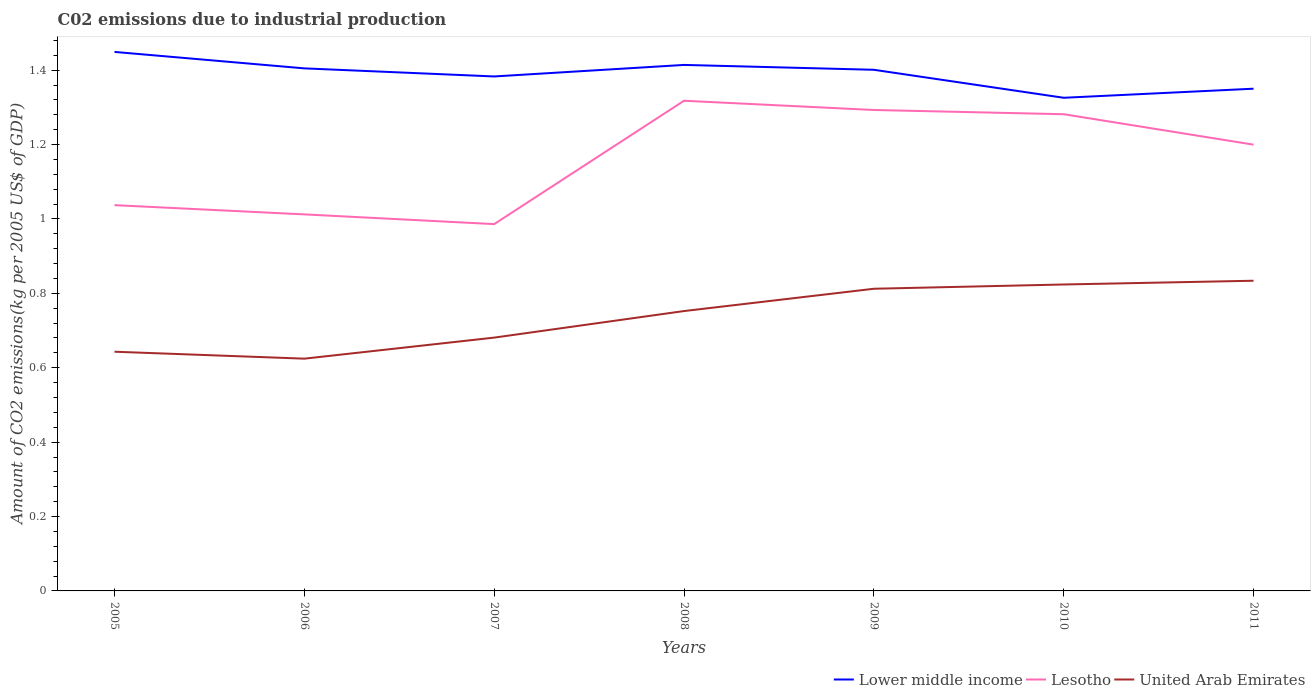How many different coloured lines are there?
Your answer should be very brief. 3. Across all years, what is the maximum amount of CO2 emitted due to industrial production in Lesotho?
Give a very brief answer. 0.99. In which year was the amount of CO2 emitted due to industrial production in Lower middle income maximum?
Offer a terse response. 2010. What is the total amount of CO2 emitted due to industrial production in Lower middle income in the graph?
Your answer should be very brief. 0.03. What is the difference between the highest and the second highest amount of CO2 emitted due to industrial production in Lesotho?
Ensure brevity in your answer.  0.33. Is the amount of CO2 emitted due to industrial production in United Arab Emirates strictly greater than the amount of CO2 emitted due to industrial production in Lower middle income over the years?
Ensure brevity in your answer.  Yes. How many lines are there?
Your answer should be compact. 3. Are the values on the major ticks of Y-axis written in scientific E-notation?
Provide a short and direct response. No. Does the graph contain any zero values?
Your response must be concise. No. Where does the legend appear in the graph?
Provide a succinct answer. Bottom right. How many legend labels are there?
Provide a succinct answer. 3. What is the title of the graph?
Your response must be concise. C02 emissions due to industrial production. Does "Papua New Guinea" appear as one of the legend labels in the graph?
Your response must be concise. No. What is the label or title of the X-axis?
Your answer should be compact. Years. What is the label or title of the Y-axis?
Your answer should be compact. Amount of CO2 emissions(kg per 2005 US$ of GDP). What is the Amount of CO2 emissions(kg per 2005 US$ of GDP) in Lower middle income in 2005?
Make the answer very short. 1.45. What is the Amount of CO2 emissions(kg per 2005 US$ of GDP) of Lesotho in 2005?
Ensure brevity in your answer.  1.04. What is the Amount of CO2 emissions(kg per 2005 US$ of GDP) of United Arab Emirates in 2005?
Your answer should be compact. 0.64. What is the Amount of CO2 emissions(kg per 2005 US$ of GDP) in Lower middle income in 2006?
Your response must be concise. 1.4. What is the Amount of CO2 emissions(kg per 2005 US$ of GDP) of Lesotho in 2006?
Your response must be concise. 1.01. What is the Amount of CO2 emissions(kg per 2005 US$ of GDP) of United Arab Emirates in 2006?
Offer a very short reply. 0.62. What is the Amount of CO2 emissions(kg per 2005 US$ of GDP) of Lower middle income in 2007?
Ensure brevity in your answer.  1.38. What is the Amount of CO2 emissions(kg per 2005 US$ of GDP) in Lesotho in 2007?
Keep it short and to the point. 0.99. What is the Amount of CO2 emissions(kg per 2005 US$ of GDP) of United Arab Emirates in 2007?
Give a very brief answer. 0.68. What is the Amount of CO2 emissions(kg per 2005 US$ of GDP) of Lower middle income in 2008?
Make the answer very short. 1.41. What is the Amount of CO2 emissions(kg per 2005 US$ of GDP) in Lesotho in 2008?
Provide a succinct answer. 1.32. What is the Amount of CO2 emissions(kg per 2005 US$ of GDP) in United Arab Emirates in 2008?
Give a very brief answer. 0.75. What is the Amount of CO2 emissions(kg per 2005 US$ of GDP) in Lower middle income in 2009?
Your response must be concise. 1.4. What is the Amount of CO2 emissions(kg per 2005 US$ of GDP) of Lesotho in 2009?
Provide a succinct answer. 1.29. What is the Amount of CO2 emissions(kg per 2005 US$ of GDP) in United Arab Emirates in 2009?
Your answer should be compact. 0.81. What is the Amount of CO2 emissions(kg per 2005 US$ of GDP) in Lower middle income in 2010?
Ensure brevity in your answer.  1.33. What is the Amount of CO2 emissions(kg per 2005 US$ of GDP) in Lesotho in 2010?
Give a very brief answer. 1.28. What is the Amount of CO2 emissions(kg per 2005 US$ of GDP) of United Arab Emirates in 2010?
Provide a succinct answer. 0.82. What is the Amount of CO2 emissions(kg per 2005 US$ of GDP) in Lower middle income in 2011?
Provide a succinct answer. 1.35. What is the Amount of CO2 emissions(kg per 2005 US$ of GDP) in Lesotho in 2011?
Provide a succinct answer. 1.2. What is the Amount of CO2 emissions(kg per 2005 US$ of GDP) in United Arab Emirates in 2011?
Make the answer very short. 0.83. Across all years, what is the maximum Amount of CO2 emissions(kg per 2005 US$ of GDP) of Lower middle income?
Offer a very short reply. 1.45. Across all years, what is the maximum Amount of CO2 emissions(kg per 2005 US$ of GDP) in Lesotho?
Keep it short and to the point. 1.32. Across all years, what is the maximum Amount of CO2 emissions(kg per 2005 US$ of GDP) of United Arab Emirates?
Provide a short and direct response. 0.83. Across all years, what is the minimum Amount of CO2 emissions(kg per 2005 US$ of GDP) of Lower middle income?
Provide a succinct answer. 1.33. Across all years, what is the minimum Amount of CO2 emissions(kg per 2005 US$ of GDP) in Lesotho?
Provide a short and direct response. 0.99. Across all years, what is the minimum Amount of CO2 emissions(kg per 2005 US$ of GDP) in United Arab Emirates?
Offer a terse response. 0.62. What is the total Amount of CO2 emissions(kg per 2005 US$ of GDP) of Lower middle income in the graph?
Offer a very short reply. 9.73. What is the total Amount of CO2 emissions(kg per 2005 US$ of GDP) in Lesotho in the graph?
Offer a very short reply. 8.13. What is the total Amount of CO2 emissions(kg per 2005 US$ of GDP) of United Arab Emirates in the graph?
Offer a terse response. 5.17. What is the difference between the Amount of CO2 emissions(kg per 2005 US$ of GDP) of Lower middle income in 2005 and that in 2006?
Your answer should be compact. 0.04. What is the difference between the Amount of CO2 emissions(kg per 2005 US$ of GDP) in Lesotho in 2005 and that in 2006?
Your answer should be compact. 0.02. What is the difference between the Amount of CO2 emissions(kg per 2005 US$ of GDP) of United Arab Emirates in 2005 and that in 2006?
Give a very brief answer. 0.02. What is the difference between the Amount of CO2 emissions(kg per 2005 US$ of GDP) of Lower middle income in 2005 and that in 2007?
Keep it short and to the point. 0.07. What is the difference between the Amount of CO2 emissions(kg per 2005 US$ of GDP) in Lesotho in 2005 and that in 2007?
Make the answer very short. 0.05. What is the difference between the Amount of CO2 emissions(kg per 2005 US$ of GDP) of United Arab Emirates in 2005 and that in 2007?
Offer a very short reply. -0.04. What is the difference between the Amount of CO2 emissions(kg per 2005 US$ of GDP) in Lower middle income in 2005 and that in 2008?
Make the answer very short. 0.04. What is the difference between the Amount of CO2 emissions(kg per 2005 US$ of GDP) of Lesotho in 2005 and that in 2008?
Your answer should be compact. -0.28. What is the difference between the Amount of CO2 emissions(kg per 2005 US$ of GDP) in United Arab Emirates in 2005 and that in 2008?
Give a very brief answer. -0.11. What is the difference between the Amount of CO2 emissions(kg per 2005 US$ of GDP) in Lower middle income in 2005 and that in 2009?
Provide a succinct answer. 0.05. What is the difference between the Amount of CO2 emissions(kg per 2005 US$ of GDP) in Lesotho in 2005 and that in 2009?
Provide a short and direct response. -0.26. What is the difference between the Amount of CO2 emissions(kg per 2005 US$ of GDP) of United Arab Emirates in 2005 and that in 2009?
Give a very brief answer. -0.17. What is the difference between the Amount of CO2 emissions(kg per 2005 US$ of GDP) in Lower middle income in 2005 and that in 2010?
Your answer should be very brief. 0.12. What is the difference between the Amount of CO2 emissions(kg per 2005 US$ of GDP) in Lesotho in 2005 and that in 2010?
Your response must be concise. -0.24. What is the difference between the Amount of CO2 emissions(kg per 2005 US$ of GDP) in United Arab Emirates in 2005 and that in 2010?
Your response must be concise. -0.18. What is the difference between the Amount of CO2 emissions(kg per 2005 US$ of GDP) of Lower middle income in 2005 and that in 2011?
Offer a terse response. 0.1. What is the difference between the Amount of CO2 emissions(kg per 2005 US$ of GDP) in Lesotho in 2005 and that in 2011?
Offer a terse response. -0.16. What is the difference between the Amount of CO2 emissions(kg per 2005 US$ of GDP) of United Arab Emirates in 2005 and that in 2011?
Give a very brief answer. -0.19. What is the difference between the Amount of CO2 emissions(kg per 2005 US$ of GDP) of Lower middle income in 2006 and that in 2007?
Offer a terse response. 0.02. What is the difference between the Amount of CO2 emissions(kg per 2005 US$ of GDP) in Lesotho in 2006 and that in 2007?
Give a very brief answer. 0.03. What is the difference between the Amount of CO2 emissions(kg per 2005 US$ of GDP) in United Arab Emirates in 2006 and that in 2007?
Your answer should be compact. -0.06. What is the difference between the Amount of CO2 emissions(kg per 2005 US$ of GDP) in Lower middle income in 2006 and that in 2008?
Make the answer very short. -0.01. What is the difference between the Amount of CO2 emissions(kg per 2005 US$ of GDP) of Lesotho in 2006 and that in 2008?
Provide a succinct answer. -0.31. What is the difference between the Amount of CO2 emissions(kg per 2005 US$ of GDP) of United Arab Emirates in 2006 and that in 2008?
Your answer should be compact. -0.13. What is the difference between the Amount of CO2 emissions(kg per 2005 US$ of GDP) of Lower middle income in 2006 and that in 2009?
Offer a terse response. 0. What is the difference between the Amount of CO2 emissions(kg per 2005 US$ of GDP) of Lesotho in 2006 and that in 2009?
Provide a short and direct response. -0.28. What is the difference between the Amount of CO2 emissions(kg per 2005 US$ of GDP) of United Arab Emirates in 2006 and that in 2009?
Your answer should be very brief. -0.19. What is the difference between the Amount of CO2 emissions(kg per 2005 US$ of GDP) of Lower middle income in 2006 and that in 2010?
Your response must be concise. 0.08. What is the difference between the Amount of CO2 emissions(kg per 2005 US$ of GDP) in Lesotho in 2006 and that in 2010?
Offer a very short reply. -0.27. What is the difference between the Amount of CO2 emissions(kg per 2005 US$ of GDP) of United Arab Emirates in 2006 and that in 2010?
Your answer should be very brief. -0.2. What is the difference between the Amount of CO2 emissions(kg per 2005 US$ of GDP) in Lower middle income in 2006 and that in 2011?
Provide a succinct answer. 0.05. What is the difference between the Amount of CO2 emissions(kg per 2005 US$ of GDP) in Lesotho in 2006 and that in 2011?
Offer a very short reply. -0.19. What is the difference between the Amount of CO2 emissions(kg per 2005 US$ of GDP) of United Arab Emirates in 2006 and that in 2011?
Provide a short and direct response. -0.21. What is the difference between the Amount of CO2 emissions(kg per 2005 US$ of GDP) of Lower middle income in 2007 and that in 2008?
Provide a succinct answer. -0.03. What is the difference between the Amount of CO2 emissions(kg per 2005 US$ of GDP) of Lesotho in 2007 and that in 2008?
Your answer should be compact. -0.33. What is the difference between the Amount of CO2 emissions(kg per 2005 US$ of GDP) in United Arab Emirates in 2007 and that in 2008?
Your answer should be very brief. -0.07. What is the difference between the Amount of CO2 emissions(kg per 2005 US$ of GDP) of Lower middle income in 2007 and that in 2009?
Offer a very short reply. -0.02. What is the difference between the Amount of CO2 emissions(kg per 2005 US$ of GDP) of Lesotho in 2007 and that in 2009?
Offer a terse response. -0.31. What is the difference between the Amount of CO2 emissions(kg per 2005 US$ of GDP) in United Arab Emirates in 2007 and that in 2009?
Make the answer very short. -0.13. What is the difference between the Amount of CO2 emissions(kg per 2005 US$ of GDP) in Lower middle income in 2007 and that in 2010?
Your answer should be compact. 0.06. What is the difference between the Amount of CO2 emissions(kg per 2005 US$ of GDP) in Lesotho in 2007 and that in 2010?
Keep it short and to the point. -0.3. What is the difference between the Amount of CO2 emissions(kg per 2005 US$ of GDP) of United Arab Emirates in 2007 and that in 2010?
Give a very brief answer. -0.14. What is the difference between the Amount of CO2 emissions(kg per 2005 US$ of GDP) in Lower middle income in 2007 and that in 2011?
Make the answer very short. 0.03. What is the difference between the Amount of CO2 emissions(kg per 2005 US$ of GDP) of Lesotho in 2007 and that in 2011?
Offer a very short reply. -0.21. What is the difference between the Amount of CO2 emissions(kg per 2005 US$ of GDP) in United Arab Emirates in 2007 and that in 2011?
Offer a very short reply. -0.15. What is the difference between the Amount of CO2 emissions(kg per 2005 US$ of GDP) in Lower middle income in 2008 and that in 2009?
Your answer should be compact. 0.01. What is the difference between the Amount of CO2 emissions(kg per 2005 US$ of GDP) of Lesotho in 2008 and that in 2009?
Offer a very short reply. 0.02. What is the difference between the Amount of CO2 emissions(kg per 2005 US$ of GDP) of United Arab Emirates in 2008 and that in 2009?
Offer a terse response. -0.06. What is the difference between the Amount of CO2 emissions(kg per 2005 US$ of GDP) in Lower middle income in 2008 and that in 2010?
Your response must be concise. 0.09. What is the difference between the Amount of CO2 emissions(kg per 2005 US$ of GDP) in Lesotho in 2008 and that in 2010?
Provide a succinct answer. 0.04. What is the difference between the Amount of CO2 emissions(kg per 2005 US$ of GDP) in United Arab Emirates in 2008 and that in 2010?
Ensure brevity in your answer.  -0.07. What is the difference between the Amount of CO2 emissions(kg per 2005 US$ of GDP) of Lower middle income in 2008 and that in 2011?
Ensure brevity in your answer.  0.06. What is the difference between the Amount of CO2 emissions(kg per 2005 US$ of GDP) in Lesotho in 2008 and that in 2011?
Keep it short and to the point. 0.12. What is the difference between the Amount of CO2 emissions(kg per 2005 US$ of GDP) of United Arab Emirates in 2008 and that in 2011?
Make the answer very short. -0.08. What is the difference between the Amount of CO2 emissions(kg per 2005 US$ of GDP) in Lower middle income in 2009 and that in 2010?
Ensure brevity in your answer.  0.08. What is the difference between the Amount of CO2 emissions(kg per 2005 US$ of GDP) in Lesotho in 2009 and that in 2010?
Offer a terse response. 0.01. What is the difference between the Amount of CO2 emissions(kg per 2005 US$ of GDP) in United Arab Emirates in 2009 and that in 2010?
Give a very brief answer. -0.01. What is the difference between the Amount of CO2 emissions(kg per 2005 US$ of GDP) of Lower middle income in 2009 and that in 2011?
Make the answer very short. 0.05. What is the difference between the Amount of CO2 emissions(kg per 2005 US$ of GDP) in Lesotho in 2009 and that in 2011?
Your answer should be very brief. 0.09. What is the difference between the Amount of CO2 emissions(kg per 2005 US$ of GDP) of United Arab Emirates in 2009 and that in 2011?
Make the answer very short. -0.02. What is the difference between the Amount of CO2 emissions(kg per 2005 US$ of GDP) of Lower middle income in 2010 and that in 2011?
Give a very brief answer. -0.02. What is the difference between the Amount of CO2 emissions(kg per 2005 US$ of GDP) in Lesotho in 2010 and that in 2011?
Provide a succinct answer. 0.08. What is the difference between the Amount of CO2 emissions(kg per 2005 US$ of GDP) of United Arab Emirates in 2010 and that in 2011?
Provide a succinct answer. -0.01. What is the difference between the Amount of CO2 emissions(kg per 2005 US$ of GDP) in Lower middle income in 2005 and the Amount of CO2 emissions(kg per 2005 US$ of GDP) in Lesotho in 2006?
Provide a short and direct response. 0.44. What is the difference between the Amount of CO2 emissions(kg per 2005 US$ of GDP) of Lower middle income in 2005 and the Amount of CO2 emissions(kg per 2005 US$ of GDP) of United Arab Emirates in 2006?
Ensure brevity in your answer.  0.82. What is the difference between the Amount of CO2 emissions(kg per 2005 US$ of GDP) of Lesotho in 2005 and the Amount of CO2 emissions(kg per 2005 US$ of GDP) of United Arab Emirates in 2006?
Your response must be concise. 0.41. What is the difference between the Amount of CO2 emissions(kg per 2005 US$ of GDP) of Lower middle income in 2005 and the Amount of CO2 emissions(kg per 2005 US$ of GDP) of Lesotho in 2007?
Provide a succinct answer. 0.46. What is the difference between the Amount of CO2 emissions(kg per 2005 US$ of GDP) of Lower middle income in 2005 and the Amount of CO2 emissions(kg per 2005 US$ of GDP) of United Arab Emirates in 2007?
Make the answer very short. 0.77. What is the difference between the Amount of CO2 emissions(kg per 2005 US$ of GDP) of Lesotho in 2005 and the Amount of CO2 emissions(kg per 2005 US$ of GDP) of United Arab Emirates in 2007?
Your response must be concise. 0.36. What is the difference between the Amount of CO2 emissions(kg per 2005 US$ of GDP) of Lower middle income in 2005 and the Amount of CO2 emissions(kg per 2005 US$ of GDP) of Lesotho in 2008?
Your answer should be compact. 0.13. What is the difference between the Amount of CO2 emissions(kg per 2005 US$ of GDP) of Lower middle income in 2005 and the Amount of CO2 emissions(kg per 2005 US$ of GDP) of United Arab Emirates in 2008?
Give a very brief answer. 0.7. What is the difference between the Amount of CO2 emissions(kg per 2005 US$ of GDP) of Lesotho in 2005 and the Amount of CO2 emissions(kg per 2005 US$ of GDP) of United Arab Emirates in 2008?
Give a very brief answer. 0.28. What is the difference between the Amount of CO2 emissions(kg per 2005 US$ of GDP) of Lower middle income in 2005 and the Amount of CO2 emissions(kg per 2005 US$ of GDP) of Lesotho in 2009?
Your answer should be compact. 0.16. What is the difference between the Amount of CO2 emissions(kg per 2005 US$ of GDP) in Lower middle income in 2005 and the Amount of CO2 emissions(kg per 2005 US$ of GDP) in United Arab Emirates in 2009?
Your answer should be very brief. 0.64. What is the difference between the Amount of CO2 emissions(kg per 2005 US$ of GDP) of Lesotho in 2005 and the Amount of CO2 emissions(kg per 2005 US$ of GDP) of United Arab Emirates in 2009?
Make the answer very short. 0.22. What is the difference between the Amount of CO2 emissions(kg per 2005 US$ of GDP) of Lower middle income in 2005 and the Amount of CO2 emissions(kg per 2005 US$ of GDP) of Lesotho in 2010?
Your response must be concise. 0.17. What is the difference between the Amount of CO2 emissions(kg per 2005 US$ of GDP) of Lower middle income in 2005 and the Amount of CO2 emissions(kg per 2005 US$ of GDP) of United Arab Emirates in 2010?
Make the answer very short. 0.63. What is the difference between the Amount of CO2 emissions(kg per 2005 US$ of GDP) in Lesotho in 2005 and the Amount of CO2 emissions(kg per 2005 US$ of GDP) in United Arab Emirates in 2010?
Your response must be concise. 0.21. What is the difference between the Amount of CO2 emissions(kg per 2005 US$ of GDP) in Lower middle income in 2005 and the Amount of CO2 emissions(kg per 2005 US$ of GDP) in Lesotho in 2011?
Offer a terse response. 0.25. What is the difference between the Amount of CO2 emissions(kg per 2005 US$ of GDP) of Lower middle income in 2005 and the Amount of CO2 emissions(kg per 2005 US$ of GDP) of United Arab Emirates in 2011?
Your answer should be very brief. 0.62. What is the difference between the Amount of CO2 emissions(kg per 2005 US$ of GDP) in Lesotho in 2005 and the Amount of CO2 emissions(kg per 2005 US$ of GDP) in United Arab Emirates in 2011?
Ensure brevity in your answer.  0.2. What is the difference between the Amount of CO2 emissions(kg per 2005 US$ of GDP) in Lower middle income in 2006 and the Amount of CO2 emissions(kg per 2005 US$ of GDP) in Lesotho in 2007?
Offer a terse response. 0.42. What is the difference between the Amount of CO2 emissions(kg per 2005 US$ of GDP) in Lower middle income in 2006 and the Amount of CO2 emissions(kg per 2005 US$ of GDP) in United Arab Emirates in 2007?
Offer a terse response. 0.72. What is the difference between the Amount of CO2 emissions(kg per 2005 US$ of GDP) of Lesotho in 2006 and the Amount of CO2 emissions(kg per 2005 US$ of GDP) of United Arab Emirates in 2007?
Your answer should be very brief. 0.33. What is the difference between the Amount of CO2 emissions(kg per 2005 US$ of GDP) of Lower middle income in 2006 and the Amount of CO2 emissions(kg per 2005 US$ of GDP) of Lesotho in 2008?
Offer a terse response. 0.09. What is the difference between the Amount of CO2 emissions(kg per 2005 US$ of GDP) in Lower middle income in 2006 and the Amount of CO2 emissions(kg per 2005 US$ of GDP) in United Arab Emirates in 2008?
Offer a very short reply. 0.65. What is the difference between the Amount of CO2 emissions(kg per 2005 US$ of GDP) in Lesotho in 2006 and the Amount of CO2 emissions(kg per 2005 US$ of GDP) in United Arab Emirates in 2008?
Provide a succinct answer. 0.26. What is the difference between the Amount of CO2 emissions(kg per 2005 US$ of GDP) of Lower middle income in 2006 and the Amount of CO2 emissions(kg per 2005 US$ of GDP) of Lesotho in 2009?
Your response must be concise. 0.11. What is the difference between the Amount of CO2 emissions(kg per 2005 US$ of GDP) in Lower middle income in 2006 and the Amount of CO2 emissions(kg per 2005 US$ of GDP) in United Arab Emirates in 2009?
Give a very brief answer. 0.59. What is the difference between the Amount of CO2 emissions(kg per 2005 US$ of GDP) of Lesotho in 2006 and the Amount of CO2 emissions(kg per 2005 US$ of GDP) of United Arab Emirates in 2009?
Keep it short and to the point. 0.2. What is the difference between the Amount of CO2 emissions(kg per 2005 US$ of GDP) in Lower middle income in 2006 and the Amount of CO2 emissions(kg per 2005 US$ of GDP) in Lesotho in 2010?
Your answer should be compact. 0.12. What is the difference between the Amount of CO2 emissions(kg per 2005 US$ of GDP) of Lower middle income in 2006 and the Amount of CO2 emissions(kg per 2005 US$ of GDP) of United Arab Emirates in 2010?
Ensure brevity in your answer.  0.58. What is the difference between the Amount of CO2 emissions(kg per 2005 US$ of GDP) in Lesotho in 2006 and the Amount of CO2 emissions(kg per 2005 US$ of GDP) in United Arab Emirates in 2010?
Your response must be concise. 0.19. What is the difference between the Amount of CO2 emissions(kg per 2005 US$ of GDP) in Lower middle income in 2006 and the Amount of CO2 emissions(kg per 2005 US$ of GDP) in Lesotho in 2011?
Ensure brevity in your answer.  0.21. What is the difference between the Amount of CO2 emissions(kg per 2005 US$ of GDP) of Lower middle income in 2006 and the Amount of CO2 emissions(kg per 2005 US$ of GDP) of United Arab Emirates in 2011?
Your answer should be compact. 0.57. What is the difference between the Amount of CO2 emissions(kg per 2005 US$ of GDP) in Lesotho in 2006 and the Amount of CO2 emissions(kg per 2005 US$ of GDP) in United Arab Emirates in 2011?
Provide a short and direct response. 0.18. What is the difference between the Amount of CO2 emissions(kg per 2005 US$ of GDP) of Lower middle income in 2007 and the Amount of CO2 emissions(kg per 2005 US$ of GDP) of Lesotho in 2008?
Ensure brevity in your answer.  0.07. What is the difference between the Amount of CO2 emissions(kg per 2005 US$ of GDP) in Lower middle income in 2007 and the Amount of CO2 emissions(kg per 2005 US$ of GDP) in United Arab Emirates in 2008?
Your answer should be very brief. 0.63. What is the difference between the Amount of CO2 emissions(kg per 2005 US$ of GDP) in Lesotho in 2007 and the Amount of CO2 emissions(kg per 2005 US$ of GDP) in United Arab Emirates in 2008?
Your answer should be very brief. 0.23. What is the difference between the Amount of CO2 emissions(kg per 2005 US$ of GDP) of Lower middle income in 2007 and the Amount of CO2 emissions(kg per 2005 US$ of GDP) of Lesotho in 2009?
Provide a succinct answer. 0.09. What is the difference between the Amount of CO2 emissions(kg per 2005 US$ of GDP) of Lower middle income in 2007 and the Amount of CO2 emissions(kg per 2005 US$ of GDP) of United Arab Emirates in 2009?
Your response must be concise. 0.57. What is the difference between the Amount of CO2 emissions(kg per 2005 US$ of GDP) in Lesotho in 2007 and the Amount of CO2 emissions(kg per 2005 US$ of GDP) in United Arab Emirates in 2009?
Ensure brevity in your answer.  0.17. What is the difference between the Amount of CO2 emissions(kg per 2005 US$ of GDP) of Lower middle income in 2007 and the Amount of CO2 emissions(kg per 2005 US$ of GDP) of Lesotho in 2010?
Offer a terse response. 0.1. What is the difference between the Amount of CO2 emissions(kg per 2005 US$ of GDP) in Lower middle income in 2007 and the Amount of CO2 emissions(kg per 2005 US$ of GDP) in United Arab Emirates in 2010?
Provide a succinct answer. 0.56. What is the difference between the Amount of CO2 emissions(kg per 2005 US$ of GDP) in Lesotho in 2007 and the Amount of CO2 emissions(kg per 2005 US$ of GDP) in United Arab Emirates in 2010?
Make the answer very short. 0.16. What is the difference between the Amount of CO2 emissions(kg per 2005 US$ of GDP) of Lower middle income in 2007 and the Amount of CO2 emissions(kg per 2005 US$ of GDP) of Lesotho in 2011?
Your answer should be compact. 0.18. What is the difference between the Amount of CO2 emissions(kg per 2005 US$ of GDP) of Lower middle income in 2007 and the Amount of CO2 emissions(kg per 2005 US$ of GDP) of United Arab Emirates in 2011?
Offer a terse response. 0.55. What is the difference between the Amount of CO2 emissions(kg per 2005 US$ of GDP) of Lesotho in 2007 and the Amount of CO2 emissions(kg per 2005 US$ of GDP) of United Arab Emirates in 2011?
Make the answer very short. 0.15. What is the difference between the Amount of CO2 emissions(kg per 2005 US$ of GDP) in Lower middle income in 2008 and the Amount of CO2 emissions(kg per 2005 US$ of GDP) in Lesotho in 2009?
Offer a terse response. 0.12. What is the difference between the Amount of CO2 emissions(kg per 2005 US$ of GDP) in Lower middle income in 2008 and the Amount of CO2 emissions(kg per 2005 US$ of GDP) in United Arab Emirates in 2009?
Provide a succinct answer. 0.6. What is the difference between the Amount of CO2 emissions(kg per 2005 US$ of GDP) in Lesotho in 2008 and the Amount of CO2 emissions(kg per 2005 US$ of GDP) in United Arab Emirates in 2009?
Keep it short and to the point. 0.51. What is the difference between the Amount of CO2 emissions(kg per 2005 US$ of GDP) of Lower middle income in 2008 and the Amount of CO2 emissions(kg per 2005 US$ of GDP) of Lesotho in 2010?
Offer a terse response. 0.13. What is the difference between the Amount of CO2 emissions(kg per 2005 US$ of GDP) in Lower middle income in 2008 and the Amount of CO2 emissions(kg per 2005 US$ of GDP) in United Arab Emirates in 2010?
Your response must be concise. 0.59. What is the difference between the Amount of CO2 emissions(kg per 2005 US$ of GDP) in Lesotho in 2008 and the Amount of CO2 emissions(kg per 2005 US$ of GDP) in United Arab Emirates in 2010?
Your answer should be compact. 0.49. What is the difference between the Amount of CO2 emissions(kg per 2005 US$ of GDP) in Lower middle income in 2008 and the Amount of CO2 emissions(kg per 2005 US$ of GDP) in Lesotho in 2011?
Make the answer very short. 0.21. What is the difference between the Amount of CO2 emissions(kg per 2005 US$ of GDP) of Lower middle income in 2008 and the Amount of CO2 emissions(kg per 2005 US$ of GDP) of United Arab Emirates in 2011?
Provide a succinct answer. 0.58. What is the difference between the Amount of CO2 emissions(kg per 2005 US$ of GDP) in Lesotho in 2008 and the Amount of CO2 emissions(kg per 2005 US$ of GDP) in United Arab Emirates in 2011?
Offer a very short reply. 0.48. What is the difference between the Amount of CO2 emissions(kg per 2005 US$ of GDP) of Lower middle income in 2009 and the Amount of CO2 emissions(kg per 2005 US$ of GDP) of Lesotho in 2010?
Provide a short and direct response. 0.12. What is the difference between the Amount of CO2 emissions(kg per 2005 US$ of GDP) of Lower middle income in 2009 and the Amount of CO2 emissions(kg per 2005 US$ of GDP) of United Arab Emirates in 2010?
Give a very brief answer. 0.58. What is the difference between the Amount of CO2 emissions(kg per 2005 US$ of GDP) in Lesotho in 2009 and the Amount of CO2 emissions(kg per 2005 US$ of GDP) in United Arab Emirates in 2010?
Provide a short and direct response. 0.47. What is the difference between the Amount of CO2 emissions(kg per 2005 US$ of GDP) in Lower middle income in 2009 and the Amount of CO2 emissions(kg per 2005 US$ of GDP) in Lesotho in 2011?
Make the answer very short. 0.2. What is the difference between the Amount of CO2 emissions(kg per 2005 US$ of GDP) of Lower middle income in 2009 and the Amount of CO2 emissions(kg per 2005 US$ of GDP) of United Arab Emirates in 2011?
Your answer should be very brief. 0.57. What is the difference between the Amount of CO2 emissions(kg per 2005 US$ of GDP) of Lesotho in 2009 and the Amount of CO2 emissions(kg per 2005 US$ of GDP) of United Arab Emirates in 2011?
Ensure brevity in your answer.  0.46. What is the difference between the Amount of CO2 emissions(kg per 2005 US$ of GDP) of Lower middle income in 2010 and the Amount of CO2 emissions(kg per 2005 US$ of GDP) of Lesotho in 2011?
Provide a short and direct response. 0.13. What is the difference between the Amount of CO2 emissions(kg per 2005 US$ of GDP) in Lower middle income in 2010 and the Amount of CO2 emissions(kg per 2005 US$ of GDP) in United Arab Emirates in 2011?
Offer a very short reply. 0.49. What is the difference between the Amount of CO2 emissions(kg per 2005 US$ of GDP) of Lesotho in 2010 and the Amount of CO2 emissions(kg per 2005 US$ of GDP) of United Arab Emirates in 2011?
Make the answer very short. 0.45. What is the average Amount of CO2 emissions(kg per 2005 US$ of GDP) of Lower middle income per year?
Make the answer very short. 1.39. What is the average Amount of CO2 emissions(kg per 2005 US$ of GDP) in Lesotho per year?
Keep it short and to the point. 1.16. What is the average Amount of CO2 emissions(kg per 2005 US$ of GDP) in United Arab Emirates per year?
Provide a short and direct response. 0.74. In the year 2005, what is the difference between the Amount of CO2 emissions(kg per 2005 US$ of GDP) in Lower middle income and Amount of CO2 emissions(kg per 2005 US$ of GDP) in Lesotho?
Keep it short and to the point. 0.41. In the year 2005, what is the difference between the Amount of CO2 emissions(kg per 2005 US$ of GDP) in Lower middle income and Amount of CO2 emissions(kg per 2005 US$ of GDP) in United Arab Emirates?
Provide a short and direct response. 0.81. In the year 2005, what is the difference between the Amount of CO2 emissions(kg per 2005 US$ of GDP) of Lesotho and Amount of CO2 emissions(kg per 2005 US$ of GDP) of United Arab Emirates?
Your response must be concise. 0.39. In the year 2006, what is the difference between the Amount of CO2 emissions(kg per 2005 US$ of GDP) of Lower middle income and Amount of CO2 emissions(kg per 2005 US$ of GDP) of Lesotho?
Provide a succinct answer. 0.39. In the year 2006, what is the difference between the Amount of CO2 emissions(kg per 2005 US$ of GDP) of Lower middle income and Amount of CO2 emissions(kg per 2005 US$ of GDP) of United Arab Emirates?
Offer a terse response. 0.78. In the year 2006, what is the difference between the Amount of CO2 emissions(kg per 2005 US$ of GDP) in Lesotho and Amount of CO2 emissions(kg per 2005 US$ of GDP) in United Arab Emirates?
Keep it short and to the point. 0.39. In the year 2007, what is the difference between the Amount of CO2 emissions(kg per 2005 US$ of GDP) in Lower middle income and Amount of CO2 emissions(kg per 2005 US$ of GDP) in Lesotho?
Ensure brevity in your answer.  0.4. In the year 2007, what is the difference between the Amount of CO2 emissions(kg per 2005 US$ of GDP) in Lower middle income and Amount of CO2 emissions(kg per 2005 US$ of GDP) in United Arab Emirates?
Make the answer very short. 0.7. In the year 2007, what is the difference between the Amount of CO2 emissions(kg per 2005 US$ of GDP) of Lesotho and Amount of CO2 emissions(kg per 2005 US$ of GDP) of United Arab Emirates?
Make the answer very short. 0.31. In the year 2008, what is the difference between the Amount of CO2 emissions(kg per 2005 US$ of GDP) of Lower middle income and Amount of CO2 emissions(kg per 2005 US$ of GDP) of Lesotho?
Your answer should be compact. 0.1. In the year 2008, what is the difference between the Amount of CO2 emissions(kg per 2005 US$ of GDP) in Lower middle income and Amount of CO2 emissions(kg per 2005 US$ of GDP) in United Arab Emirates?
Provide a succinct answer. 0.66. In the year 2008, what is the difference between the Amount of CO2 emissions(kg per 2005 US$ of GDP) of Lesotho and Amount of CO2 emissions(kg per 2005 US$ of GDP) of United Arab Emirates?
Ensure brevity in your answer.  0.57. In the year 2009, what is the difference between the Amount of CO2 emissions(kg per 2005 US$ of GDP) of Lower middle income and Amount of CO2 emissions(kg per 2005 US$ of GDP) of Lesotho?
Ensure brevity in your answer.  0.11. In the year 2009, what is the difference between the Amount of CO2 emissions(kg per 2005 US$ of GDP) in Lower middle income and Amount of CO2 emissions(kg per 2005 US$ of GDP) in United Arab Emirates?
Give a very brief answer. 0.59. In the year 2009, what is the difference between the Amount of CO2 emissions(kg per 2005 US$ of GDP) in Lesotho and Amount of CO2 emissions(kg per 2005 US$ of GDP) in United Arab Emirates?
Make the answer very short. 0.48. In the year 2010, what is the difference between the Amount of CO2 emissions(kg per 2005 US$ of GDP) of Lower middle income and Amount of CO2 emissions(kg per 2005 US$ of GDP) of Lesotho?
Keep it short and to the point. 0.04. In the year 2010, what is the difference between the Amount of CO2 emissions(kg per 2005 US$ of GDP) in Lower middle income and Amount of CO2 emissions(kg per 2005 US$ of GDP) in United Arab Emirates?
Give a very brief answer. 0.5. In the year 2010, what is the difference between the Amount of CO2 emissions(kg per 2005 US$ of GDP) in Lesotho and Amount of CO2 emissions(kg per 2005 US$ of GDP) in United Arab Emirates?
Ensure brevity in your answer.  0.46. In the year 2011, what is the difference between the Amount of CO2 emissions(kg per 2005 US$ of GDP) in Lower middle income and Amount of CO2 emissions(kg per 2005 US$ of GDP) in Lesotho?
Provide a short and direct response. 0.15. In the year 2011, what is the difference between the Amount of CO2 emissions(kg per 2005 US$ of GDP) of Lower middle income and Amount of CO2 emissions(kg per 2005 US$ of GDP) of United Arab Emirates?
Ensure brevity in your answer.  0.52. In the year 2011, what is the difference between the Amount of CO2 emissions(kg per 2005 US$ of GDP) in Lesotho and Amount of CO2 emissions(kg per 2005 US$ of GDP) in United Arab Emirates?
Give a very brief answer. 0.37. What is the ratio of the Amount of CO2 emissions(kg per 2005 US$ of GDP) of Lower middle income in 2005 to that in 2006?
Your answer should be very brief. 1.03. What is the ratio of the Amount of CO2 emissions(kg per 2005 US$ of GDP) of Lesotho in 2005 to that in 2006?
Give a very brief answer. 1.02. What is the ratio of the Amount of CO2 emissions(kg per 2005 US$ of GDP) in United Arab Emirates in 2005 to that in 2006?
Keep it short and to the point. 1.03. What is the ratio of the Amount of CO2 emissions(kg per 2005 US$ of GDP) in Lower middle income in 2005 to that in 2007?
Give a very brief answer. 1.05. What is the ratio of the Amount of CO2 emissions(kg per 2005 US$ of GDP) of Lesotho in 2005 to that in 2007?
Your answer should be very brief. 1.05. What is the ratio of the Amount of CO2 emissions(kg per 2005 US$ of GDP) in United Arab Emirates in 2005 to that in 2007?
Provide a short and direct response. 0.94. What is the ratio of the Amount of CO2 emissions(kg per 2005 US$ of GDP) in Lower middle income in 2005 to that in 2008?
Provide a short and direct response. 1.02. What is the ratio of the Amount of CO2 emissions(kg per 2005 US$ of GDP) of Lesotho in 2005 to that in 2008?
Offer a terse response. 0.79. What is the ratio of the Amount of CO2 emissions(kg per 2005 US$ of GDP) of United Arab Emirates in 2005 to that in 2008?
Provide a succinct answer. 0.85. What is the ratio of the Amount of CO2 emissions(kg per 2005 US$ of GDP) in Lower middle income in 2005 to that in 2009?
Keep it short and to the point. 1.03. What is the ratio of the Amount of CO2 emissions(kg per 2005 US$ of GDP) of Lesotho in 2005 to that in 2009?
Make the answer very short. 0.8. What is the ratio of the Amount of CO2 emissions(kg per 2005 US$ of GDP) in United Arab Emirates in 2005 to that in 2009?
Offer a very short reply. 0.79. What is the ratio of the Amount of CO2 emissions(kg per 2005 US$ of GDP) of Lower middle income in 2005 to that in 2010?
Provide a short and direct response. 1.09. What is the ratio of the Amount of CO2 emissions(kg per 2005 US$ of GDP) in Lesotho in 2005 to that in 2010?
Offer a terse response. 0.81. What is the ratio of the Amount of CO2 emissions(kg per 2005 US$ of GDP) of United Arab Emirates in 2005 to that in 2010?
Your response must be concise. 0.78. What is the ratio of the Amount of CO2 emissions(kg per 2005 US$ of GDP) of Lower middle income in 2005 to that in 2011?
Provide a succinct answer. 1.07. What is the ratio of the Amount of CO2 emissions(kg per 2005 US$ of GDP) in Lesotho in 2005 to that in 2011?
Offer a terse response. 0.86. What is the ratio of the Amount of CO2 emissions(kg per 2005 US$ of GDP) of United Arab Emirates in 2005 to that in 2011?
Make the answer very short. 0.77. What is the ratio of the Amount of CO2 emissions(kg per 2005 US$ of GDP) in Lower middle income in 2006 to that in 2007?
Your answer should be compact. 1.02. What is the ratio of the Amount of CO2 emissions(kg per 2005 US$ of GDP) of Lesotho in 2006 to that in 2007?
Your answer should be compact. 1.03. What is the ratio of the Amount of CO2 emissions(kg per 2005 US$ of GDP) of United Arab Emirates in 2006 to that in 2007?
Make the answer very short. 0.92. What is the ratio of the Amount of CO2 emissions(kg per 2005 US$ of GDP) in Lower middle income in 2006 to that in 2008?
Your answer should be compact. 0.99. What is the ratio of the Amount of CO2 emissions(kg per 2005 US$ of GDP) in Lesotho in 2006 to that in 2008?
Keep it short and to the point. 0.77. What is the ratio of the Amount of CO2 emissions(kg per 2005 US$ of GDP) in United Arab Emirates in 2006 to that in 2008?
Give a very brief answer. 0.83. What is the ratio of the Amount of CO2 emissions(kg per 2005 US$ of GDP) in Lower middle income in 2006 to that in 2009?
Your response must be concise. 1. What is the ratio of the Amount of CO2 emissions(kg per 2005 US$ of GDP) in Lesotho in 2006 to that in 2009?
Your response must be concise. 0.78. What is the ratio of the Amount of CO2 emissions(kg per 2005 US$ of GDP) of United Arab Emirates in 2006 to that in 2009?
Your response must be concise. 0.77. What is the ratio of the Amount of CO2 emissions(kg per 2005 US$ of GDP) in Lower middle income in 2006 to that in 2010?
Offer a terse response. 1.06. What is the ratio of the Amount of CO2 emissions(kg per 2005 US$ of GDP) of Lesotho in 2006 to that in 2010?
Your answer should be compact. 0.79. What is the ratio of the Amount of CO2 emissions(kg per 2005 US$ of GDP) of United Arab Emirates in 2006 to that in 2010?
Make the answer very short. 0.76. What is the ratio of the Amount of CO2 emissions(kg per 2005 US$ of GDP) of Lower middle income in 2006 to that in 2011?
Ensure brevity in your answer.  1.04. What is the ratio of the Amount of CO2 emissions(kg per 2005 US$ of GDP) in Lesotho in 2006 to that in 2011?
Offer a very short reply. 0.84. What is the ratio of the Amount of CO2 emissions(kg per 2005 US$ of GDP) of United Arab Emirates in 2006 to that in 2011?
Keep it short and to the point. 0.75. What is the ratio of the Amount of CO2 emissions(kg per 2005 US$ of GDP) in Lower middle income in 2007 to that in 2008?
Ensure brevity in your answer.  0.98. What is the ratio of the Amount of CO2 emissions(kg per 2005 US$ of GDP) in Lesotho in 2007 to that in 2008?
Offer a terse response. 0.75. What is the ratio of the Amount of CO2 emissions(kg per 2005 US$ of GDP) in United Arab Emirates in 2007 to that in 2008?
Offer a very short reply. 0.91. What is the ratio of the Amount of CO2 emissions(kg per 2005 US$ of GDP) of Lower middle income in 2007 to that in 2009?
Provide a succinct answer. 0.99. What is the ratio of the Amount of CO2 emissions(kg per 2005 US$ of GDP) in Lesotho in 2007 to that in 2009?
Offer a very short reply. 0.76. What is the ratio of the Amount of CO2 emissions(kg per 2005 US$ of GDP) in United Arab Emirates in 2007 to that in 2009?
Make the answer very short. 0.84. What is the ratio of the Amount of CO2 emissions(kg per 2005 US$ of GDP) in Lower middle income in 2007 to that in 2010?
Provide a short and direct response. 1.04. What is the ratio of the Amount of CO2 emissions(kg per 2005 US$ of GDP) of Lesotho in 2007 to that in 2010?
Offer a very short reply. 0.77. What is the ratio of the Amount of CO2 emissions(kg per 2005 US$ of GDP) of United Arab Emirates in 2007 to that in 2010?
Make the answer very short. 0.83. What is the ratio of the Amount of CO2 emissions(kg per 2005 US$ of GDP) in Lower middle income in 2007 to that in 2011?
Provide a short and direct response. 1.02. What is the ratio of the Amount of CO2 emissions(kg per 2005 US$ of GDP) in Lesotho in 2007 to that in 2011?
Your answer should be very brief. 0.82. What is the ratio of the Amount of CO2 emissions(kg per 2005 US$ of GDP) of United Arab Emirates in 2007 to that in 2011?
Your answer should be very brief. 0.82. What is the ratio of the Amount of CO2 emissions(kg per 2005 US$ of GDP) in Lower middle income in 2008 to that in 2009?
Make the answer very short. 1.01. What is the ratio of the Amount of CO2 emissions(kg per 2005 US$ of GDP) in Lesotho in 2008 to that in 2009?
Offer a very short reply. 1.02. What is the ratio of the Amount of CO2 emissions(kg per 2005 US$ of GDP) of United Arab Emirates in 2008 to that in 2009?
Offer a very short reply. 0.93. What is the ratio of the Amount of CO2 emissions(kg per 2005 US$ of GDP) in Lower middle income in 2008 to that in 2010?
Keep it short and to the point. 1.07. What is the ratio of the Amount of CO2 emissions(kg per 2005 US$ of GDP) in Lesotho in 2008 to that in 2010?
Your answer should be compact. 1.03. What is the ratio of the Amount of CO2 emissions(kg per 2005 US$ of GDP) in United Arab Emirates in 2008 to that in 2010?
Provide a succinct answer. 0.91. What is the ratio of the Amount of CO2 emissions(kg per 2005 US$ of GDP) of Lower middle income in 2008 to that in 2011?
Your response must be concise. 1.05. What is the ratio of the Amount of CO2 emissions(kg per 2005 US$ of GDP) of Lesotho in 2008 to that in 2011?
Provide a short and direct response. 1.1. What is the ratio of the Amount of CO2 emissions(kg per 2005 US$ of GDP) in United Arab Emirates in 2008 to that in 2011?
Your answer should be very brief. 0.9. What is the ratio of the Amount of CO2 emissions(kg per 2005 US$ of GDP) of Lower middle income in 2009 to that in 2010?
Your answer should be compact. 1.06. What is the ratio of the Amount of CO2 emissions(kg per 2005 US$ of GDP) in Lesotho in 2009 to that in 2010?
Keep it short and to the point. 1.01. What is the ratio of the Amount of CO2 emissions(kg per 2005 US$ of GDP) of United Arab Emirates in 2009 to that in 2010?
Offer a terse response. 0.99. What is the ratio of the Amount of CO2 emissions(kg per 2005 US$ of GDP) of Lower middle income in 2009 to that in 2011?
Ensure brevity in your answer.  1.04. What is the ratio of the Amount of CO2 emissions(kg per 2005 US$ of GDP) in Lesotho in 2009 to that in 2011?
Keep it short and to the point. 1.08. What is the ratio of the Amount of CO2 emissions(kg per 2005 US$ of GDP) in United Arab Emirates in 2009 to that in 2011?
Offer a very short reply. 0.97. What is the ratio of the Amount of CO2 emissions(kg per 2005 US$ of GDP) in Lower middle income in 2010 to that in 2011?
Your answer should be compact. 0.98. What is the ratio of the Amount of CO2 emissions(kg per 2005 US$ of GDP) in Lesotho in 2010 to that in 2011?
Ensure brevity in your answer.  1.07. What is the ratio of the Amount of CO2 emissions(kg per 2005 US$ of GDP) of United Arab Emirates in 2010 to that in 2011?
Provide a succinct answer. 0.99. What is the difference between the highest and the second highest Amount of CO2 emissions(kg per 2005 US$ of GDP) in Lower middle income?
Your response must be concise. 0.04. What is the difference between the highest and the second highest Amount of CO2 emissions(kg per 2005 US$ of GDP) of Lesotho?
Provide a short and direct response. 0.02. What is the difference between the highest and the second highest Amount of CO2 emissions(kg per 2005 US$ of GDP) in United Arab Emirates?
Ensure brevity in your answer.  0.01. What is the difference between the highest and the lowest Amount of CO2 emissions(kg per 2005 US$ of GDP) of Lower middle income?
Make the answer very short. 0.12. What is the difference between the highest and the lowest Amount of CO2 emissions(kg per 2005 US$ of GDP) of Lesotho?
Your answer should be compact. 0.33. What is the difference between the highest and the lowest Amount of CO2 emissions(kg per 2005 US$ of GDP) in United Arab Emirates?
Your response must be concise. 0.21. 